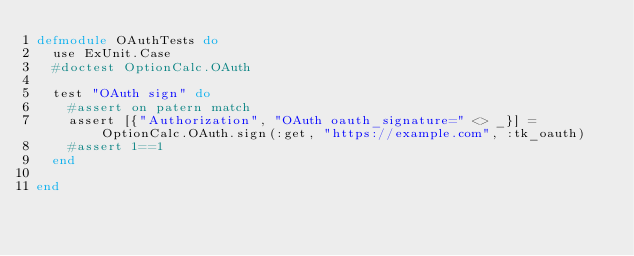<code> <loc_0><loc_0><loc_500><loc_500><_Elixir_>defmodule OAuthTests do
  use ExUnit.Case
  #doctest OptionCalc.OAuth

  test "OAuth sign" do
    #assert on patern match 
    assert [{"Authorization", "OAuth oauth_signature=" <> _}] = OptionCalc.OAuth.sign(:get, "https://example.com", :tk_oauth)
    #assert 1==1
  end

end
</code> 